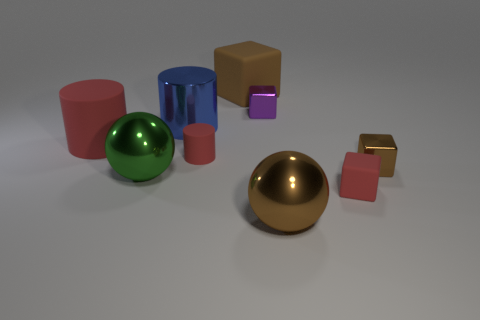How many rubber objects are either tiny green balls or purple objects?
Provide a succinct answer. 0. There is a small metal thing that is the same color as the large rubber cube; what shape is it?
Ensure brevity in your answer.  Cube. Do the large shiny sphere in front of the small rubber block and the large block have the same color?
Give a very brief answer. Yes. There is a large thing to the right of the large rubber cube right of the big green metal thing; what shape is it?
Provide a succinct answer. Sphere. What number of objects are large brown objects behind the large brown shiny ball or cubes in front of the small purple thing?
Ensure brevity in your answer.  3. The big red thing that is made of the same material as the large cube is what shape?
Provide a short and direct response. Cylinder. Is there anything else that is the same color as the shiny cylinder?
Your answer should be very brief. No. There is a tiny brown thing that is the same shape as the purple metal object; what is its material?
Your answer should be compact. Metal. How many other things are there of the same size as the brown matte object?
Make the answer very short. 4. What material is the tiny brown thing?
Provide a succinct answer. Metal. 